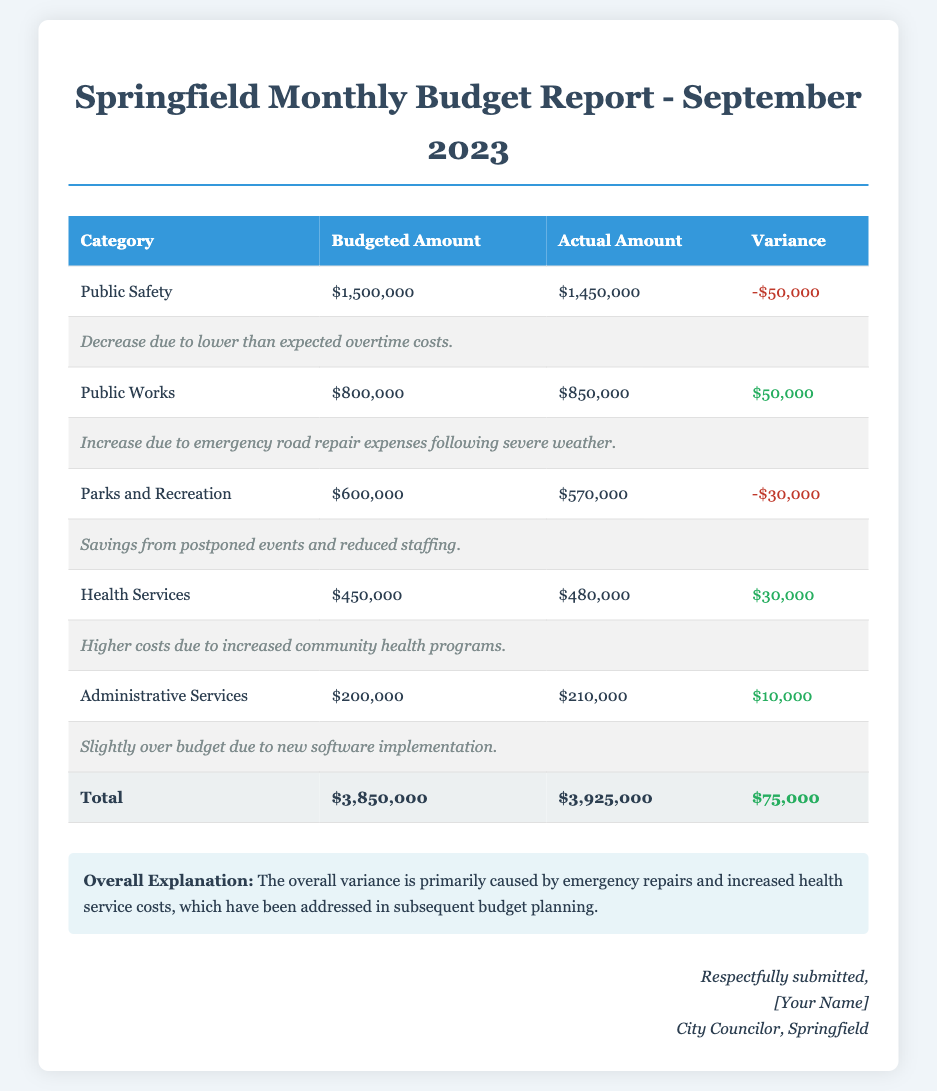What is the budgeted amount for Public Safety? The budgeted amount for Public Safety is stated directly in the table for the category.
Answer: $1,500,000 What is the variance for Parks and Recreation? The variance for Parks and Recreation is calculated based on the actual spending versus the budgeted amount, which is listed in the document.
Answer: -$30,000 How much was spent on Health Services? The actual amount spent on Health Services is provided in the table under the respective category.
Answer: $480,000 What category had the highest over-budget amount? The highest over-budget amount is determined by examining the variances for each category listed in the document.
Answer: Public Works What is the total budgeted amount for all categories combined? The total budgeted amount is listed at the end of the table in the totals row.
Answer: $3,850,000 What overall explanation is provided for the budget variances? The overall explanation addresses the primary reasons for the variances in the budget, which is included after the detailed table.
Answer: Emergency repairs and increased health service costs What is the actual total amount spent for the month? The actual total amount is indicated in the totals row of the table, summarizing all spending.
Answer: $3,925,000 How much over or under budget is the city council for the month? This is determined by the total variance, which is calculated by comparing total actual versus budgeted amounts.
Answer: $75,000 